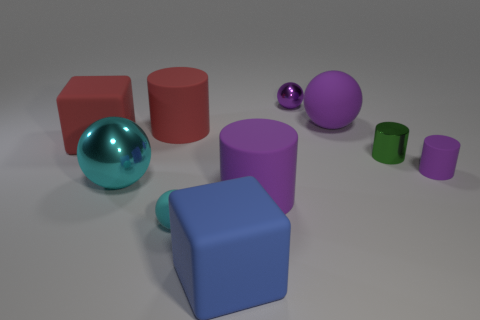Is the large shiny sphere the same color as the small rubber ball?
Offer a very short reply. Yes. Are there more tiny green cylinders right of the large purple matte ball than tiny cyan metallic balls?
Offer a very short reply. Yes. How many other things are there of the same size as the cyan shiny sphere?
Offer a very short reply. 5. What number of tiny metal objects are in front of the small green metal cylinder?
Keep it short and to the point. 0. Are there the same number of red things that are left of the large metallic sphere and cyan rubber spheres that are in front of the small rubber sphere?
Make the answer very short. No. What size is the purple rubber object that is the same shape as the large cyan metallic object?
Provide a succinct answer. Large. What shape is the tiny rubber object in front of the large cyan thing?
Offer a very short reply. Sphere. Do the big purple thing that is behind the small metal cylinder and the green thing that is in front of the tiny purple shiny sphere have the same material?
Make the answer very short. No. The large cyan object is what shape?
Ensure brevity in your answer.  Sphere. Are there the same number of cyan things that are on the right side of the big cyan metallic object and tiny cyan rubber objects?
Your response must be concise. Yes. 